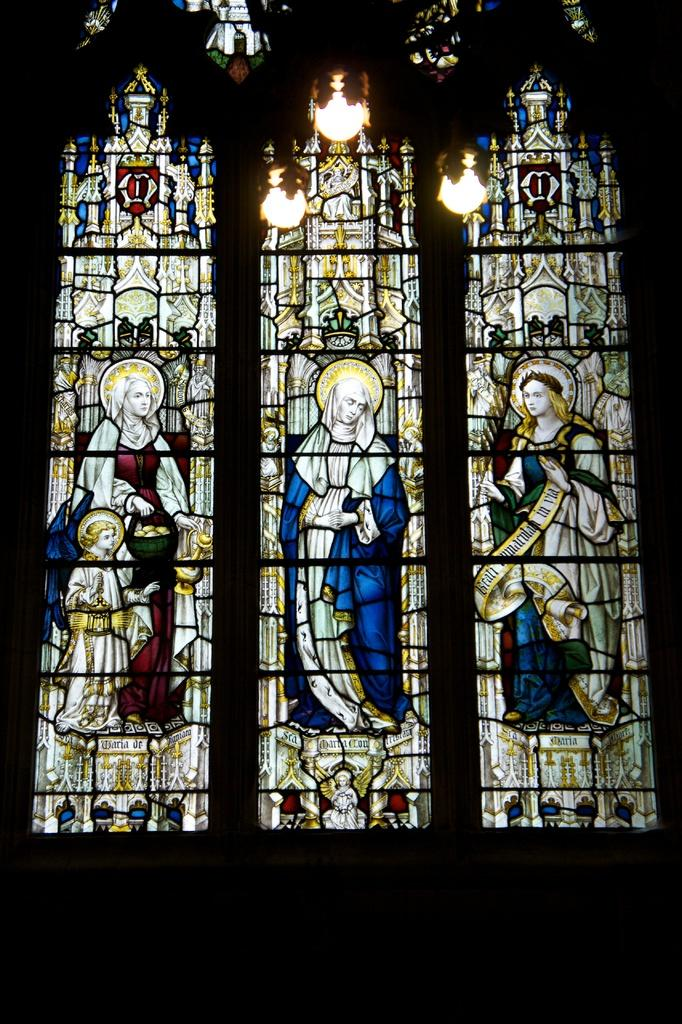What type of location is depicted in the image? The image shows an inside view of a church. What can be seen on the wall in the image? There is a wall with painted images of persons in the image. What is visible at the top of the image? There are lights visible at the top of the image. What type of carriage is parked outside the church in the image? There is no carriage visible in the image, as it shows an inside view of the church. What kind of tools does the carpenter have in the image? There is no carpenter or tools present in the image; it only shows the inside of a church. 